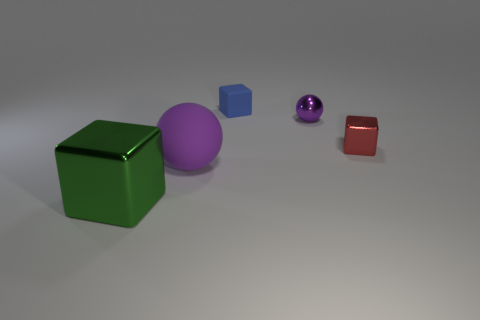Is the large matte object the same color as the large metal thing?
Your answer should be compact. No. What number of things are either small red objects or objects that are on the right side of the large green block?
Your response must be concise. 4. Is there another green metal object that has the same size as the green object?
Offer a very short reply. No. Does the blue cube have the same material as the tiny ball?
Offer a terse response. No. How many objects are either small objects or matte things?
Offer a very short reply. 4. What size is the red cube?
Offer a terse response. Small. Are there fewer purple things than gray metallic objects?
Provide a short and direct response. No. What number of small balls are the same color as the matte block?
Your response must be concise. 0. There is a metal block to the left of the matte block; does it have the same color as the big ball?
Your response must be concise. No. What is the shape of the big green object that is left of the tiny blue rubber block?
Your answer should be compact. Cube. 